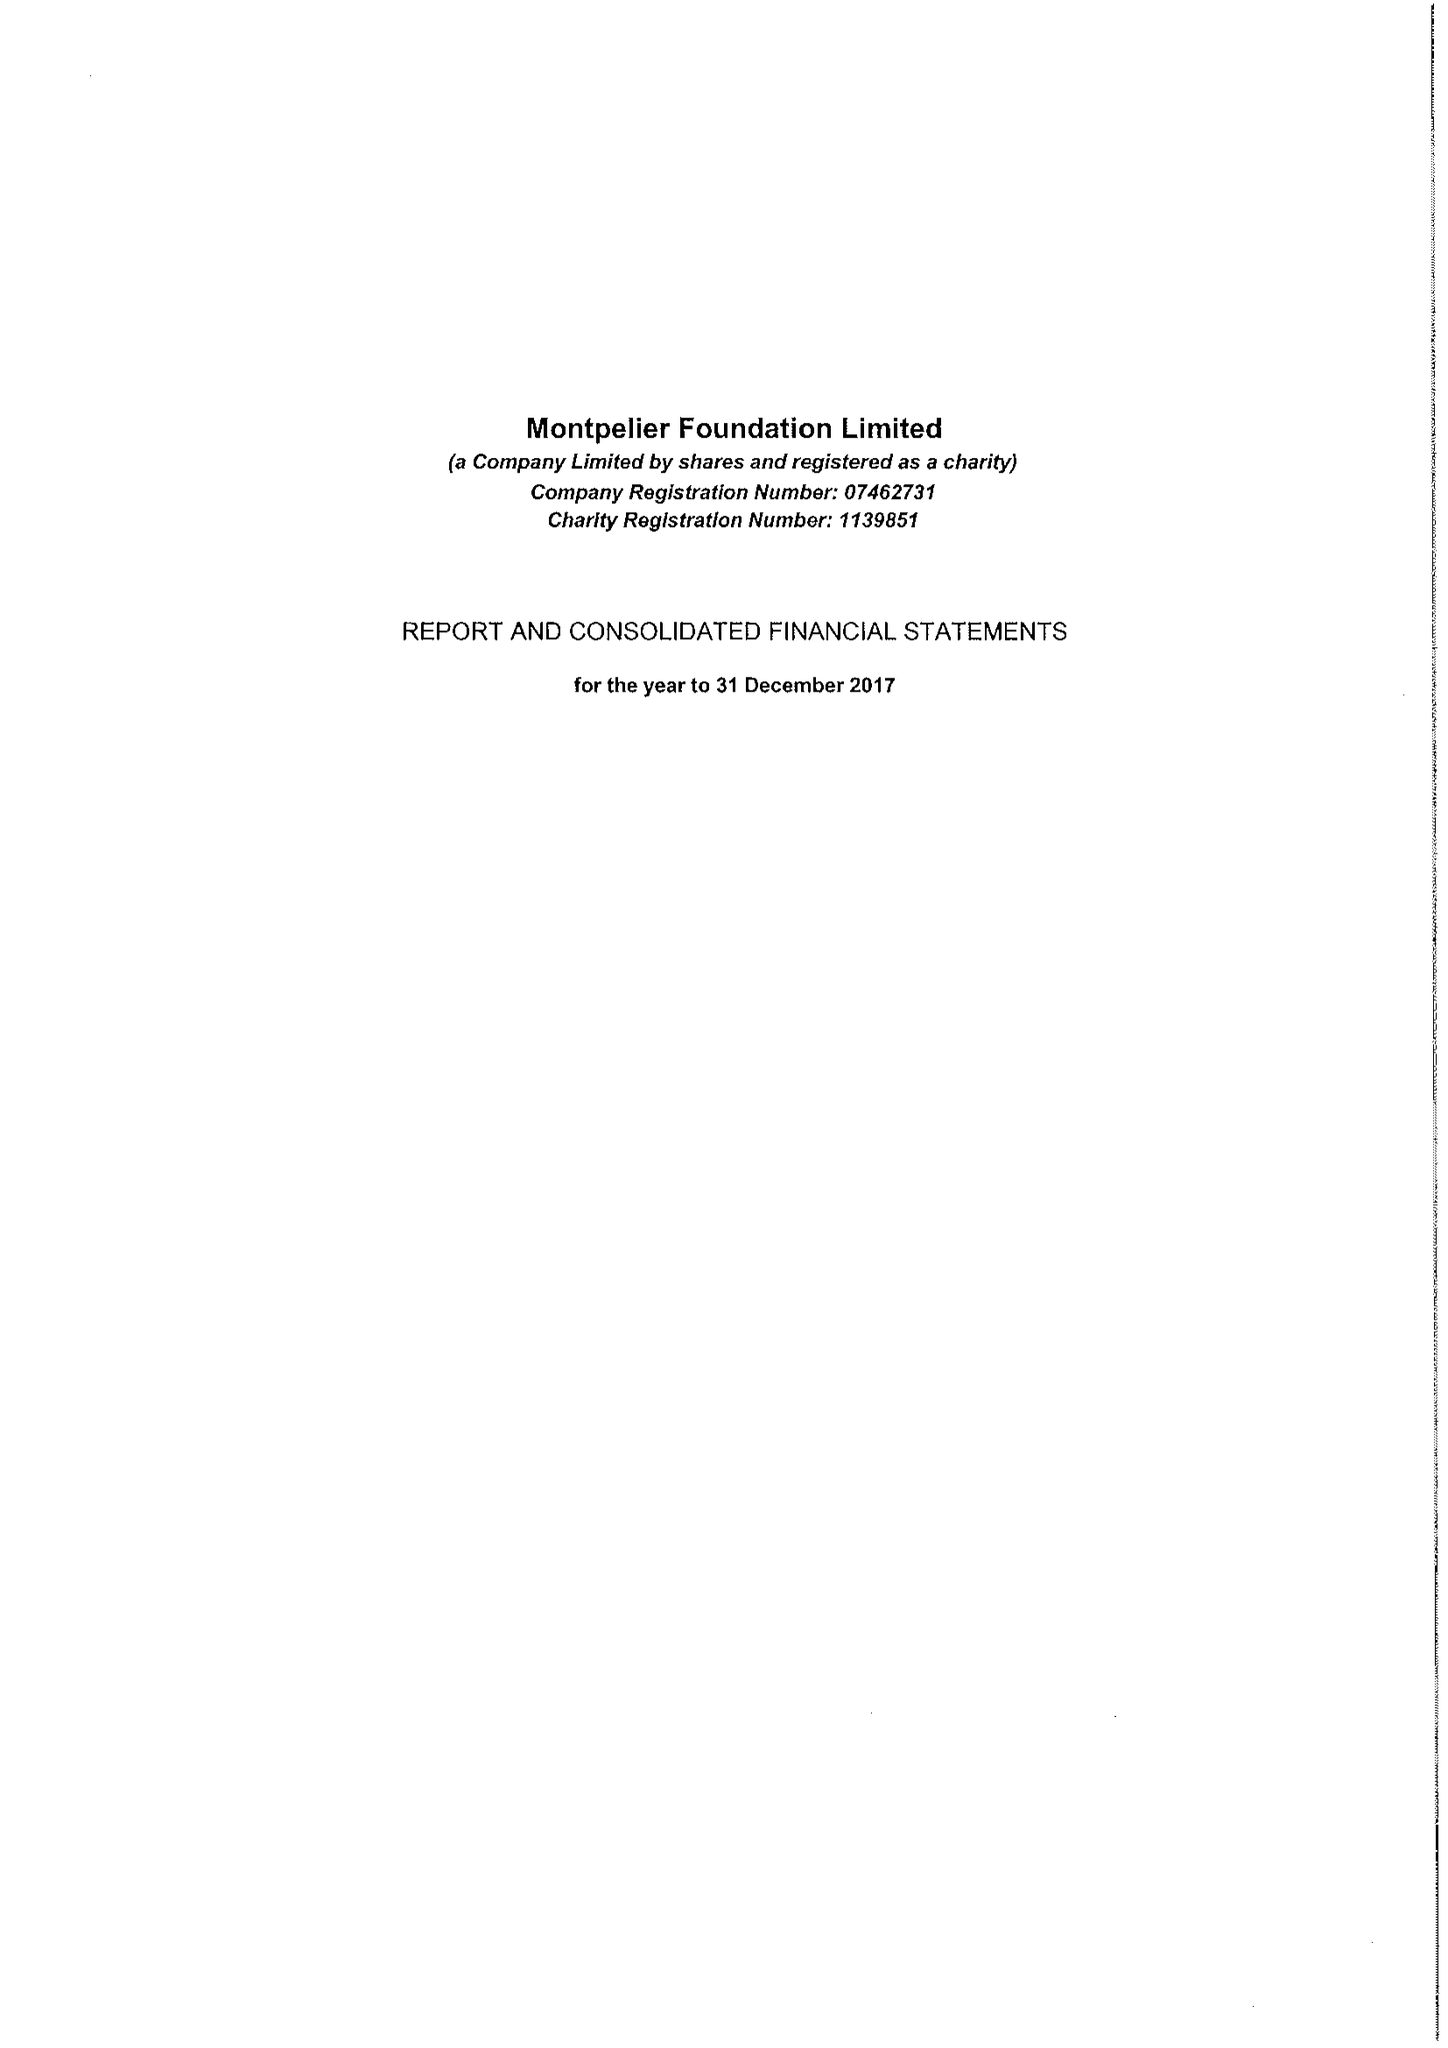What is the value for the income_annually_in_british_pounds?
Answer the question using a single word or phrase. 385676.00 